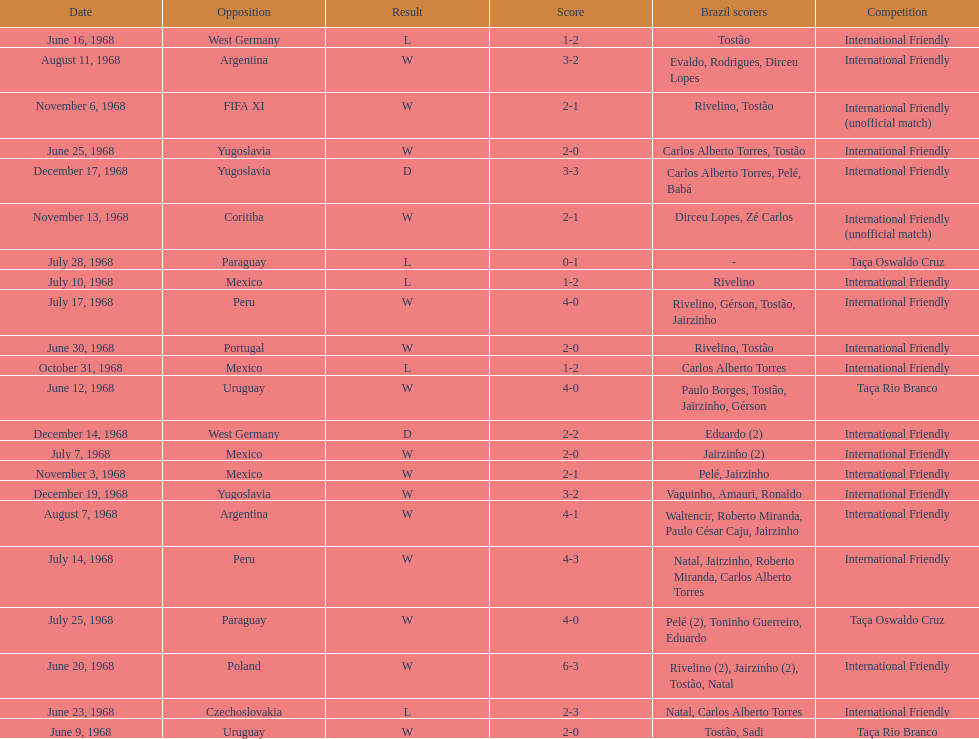How many losses are there? 5. 